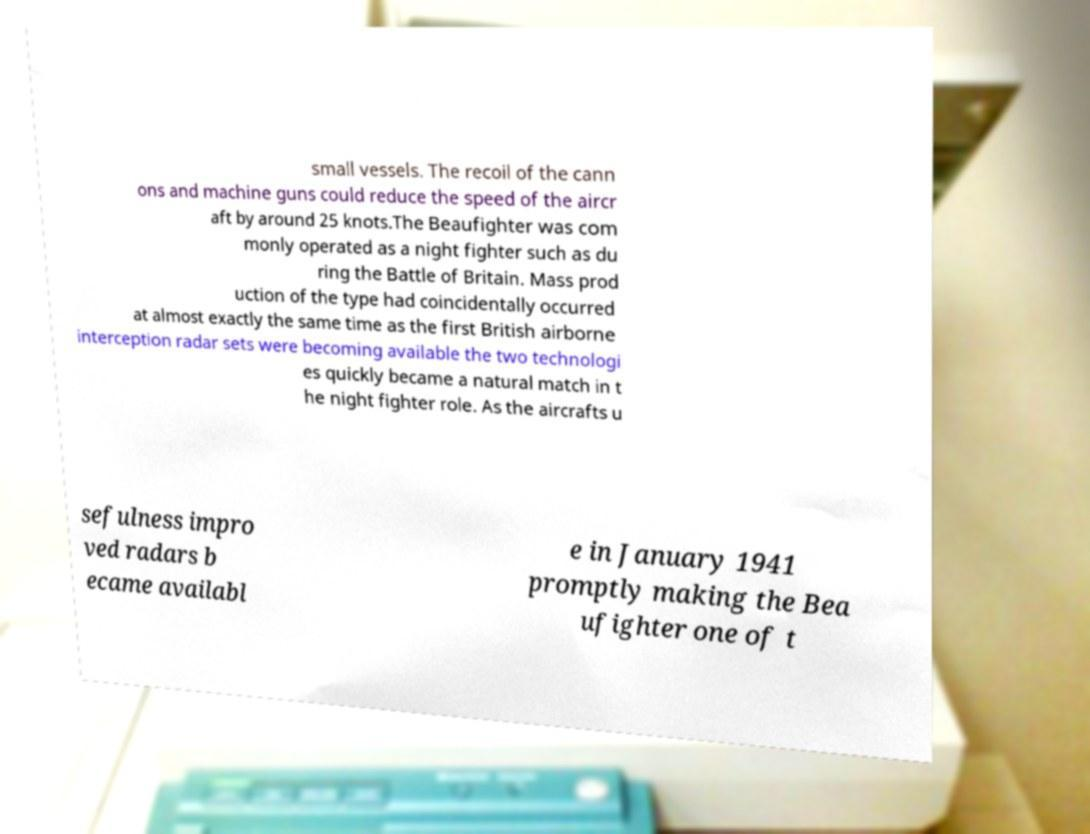Could you extract and type out the text from this image? small vessels. The recoil of the cann ons and machine guns could reduce the speed of the aircr aft by around 25 knots.The Beaufighter was com monly operated as a night fighter such as du ring the Battle of Britain. Mass prod uction of the type had coincidentally occurred at almost exactly the same time as the first British airborne interception radar sets were becoming available the two technologi es quickly became a natural match in t he night fighter role. As the aircrafts u sefulness impro ved radars b ecame availabl e in January 1941 promptly making the Bea ufighter one of t 